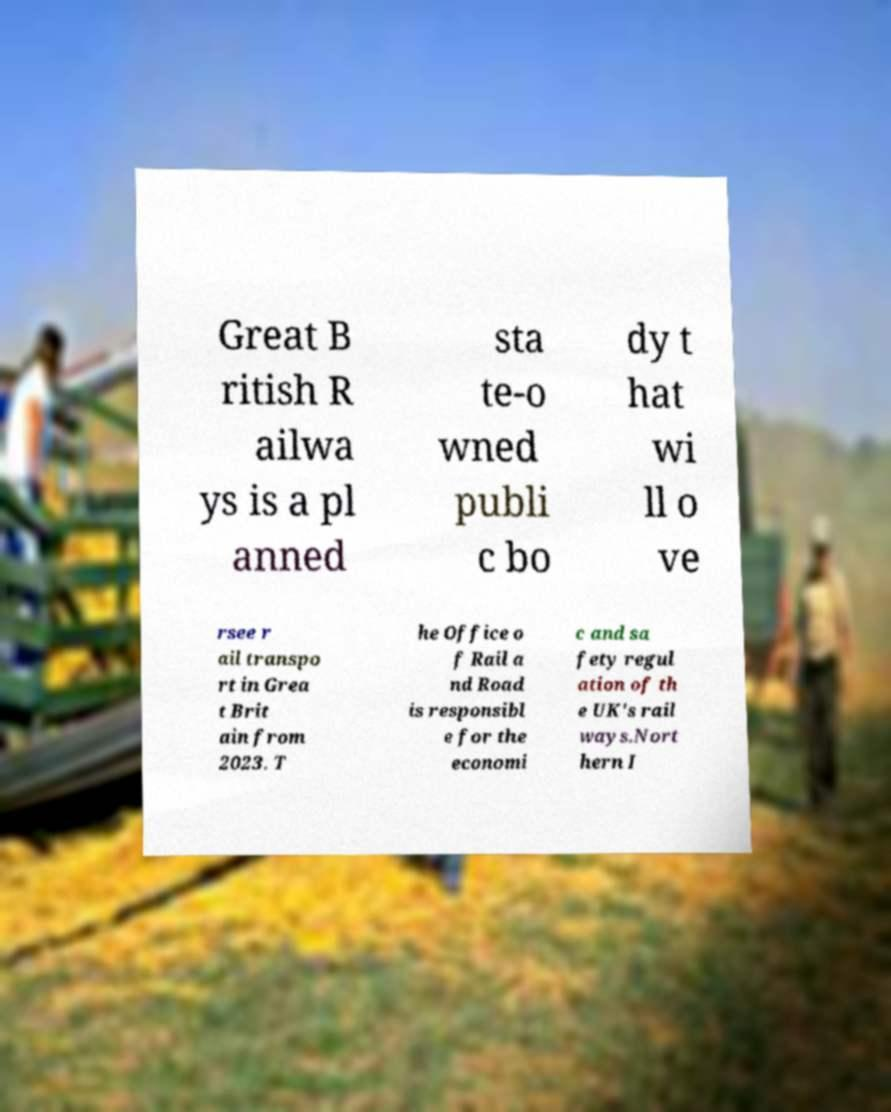Please read and relay the text visible in this image. What does it say? Great B ritish R ailwa ys is a pl anned sta te-o wned publi c bo dy t hat wi ll o ve rsee r ail transpo rt in Grea t Brit ain from 2023. T he Office o f Rail a nd Road is responsibl e for the economi c and sa fety regul ation of th e UK's rail ways.Nort hern I 